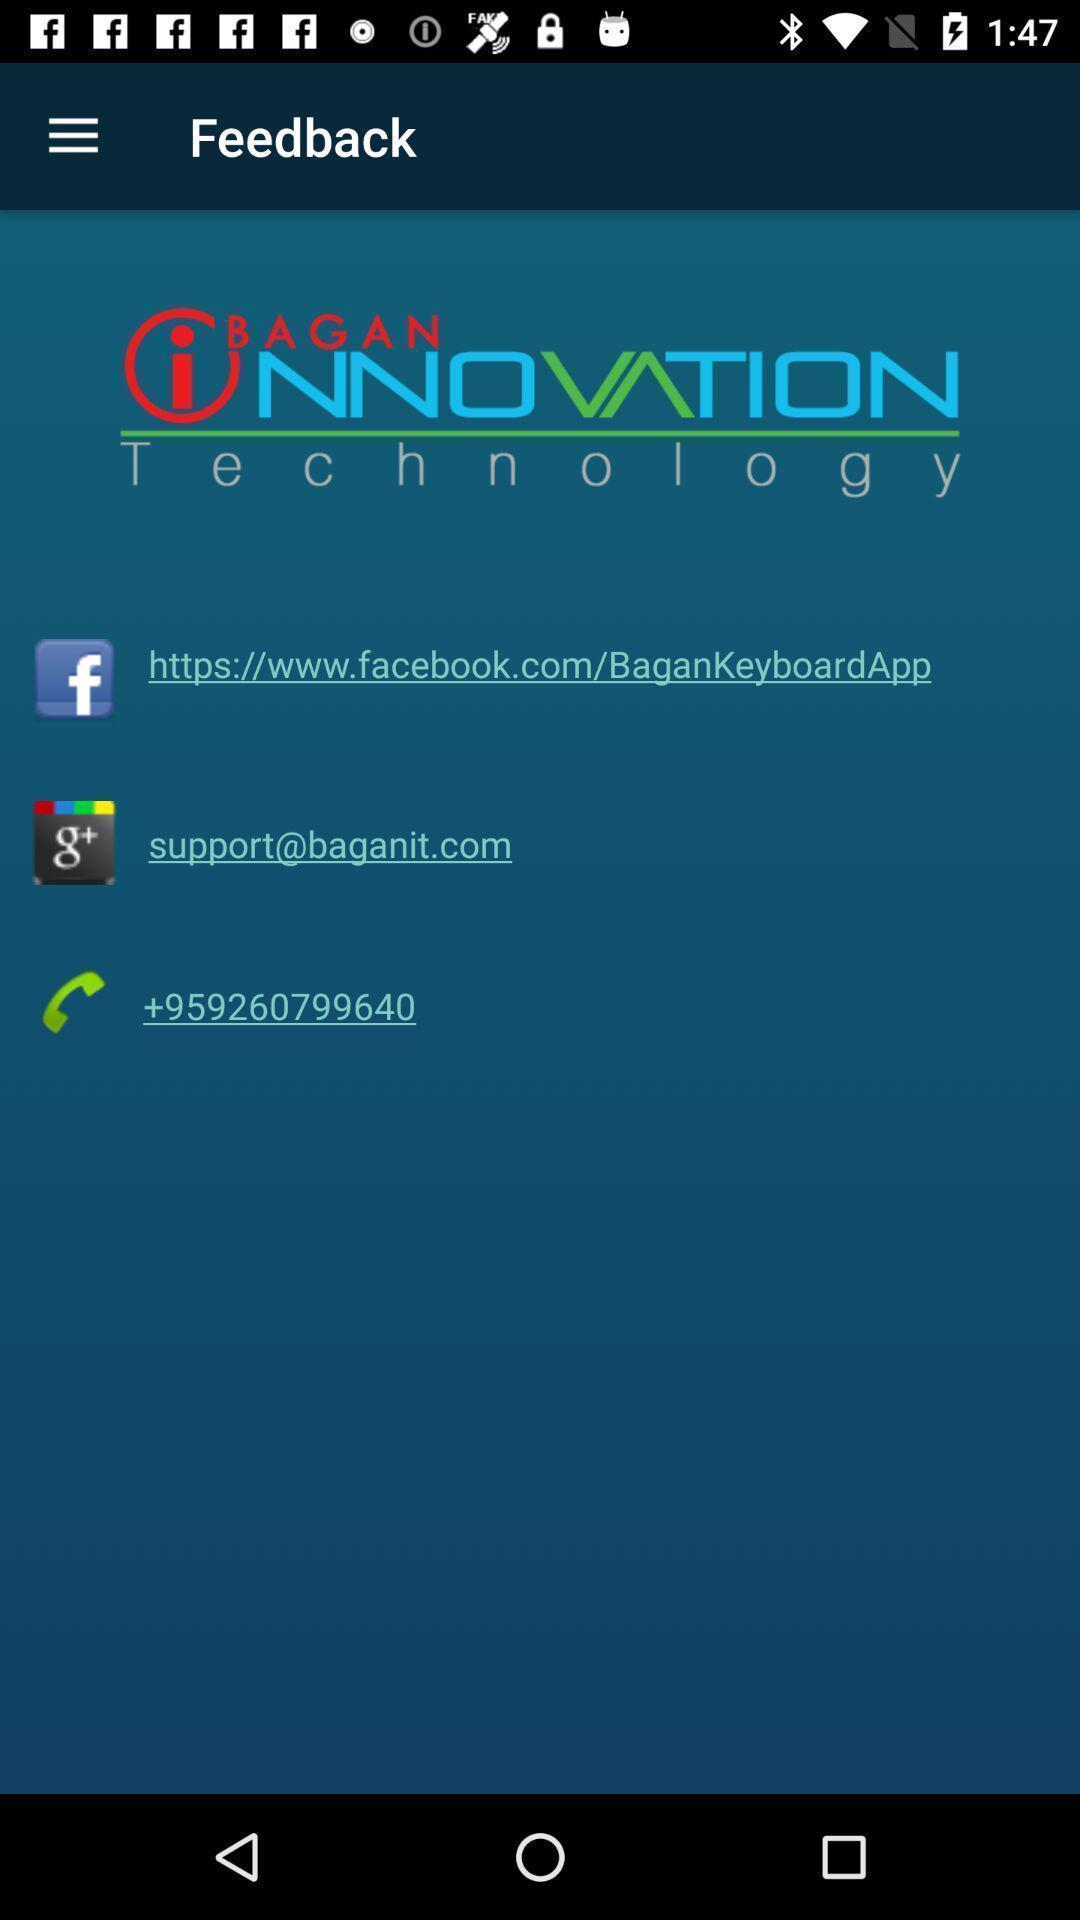Describe the content in this image. Screen shows about giving feedback. 